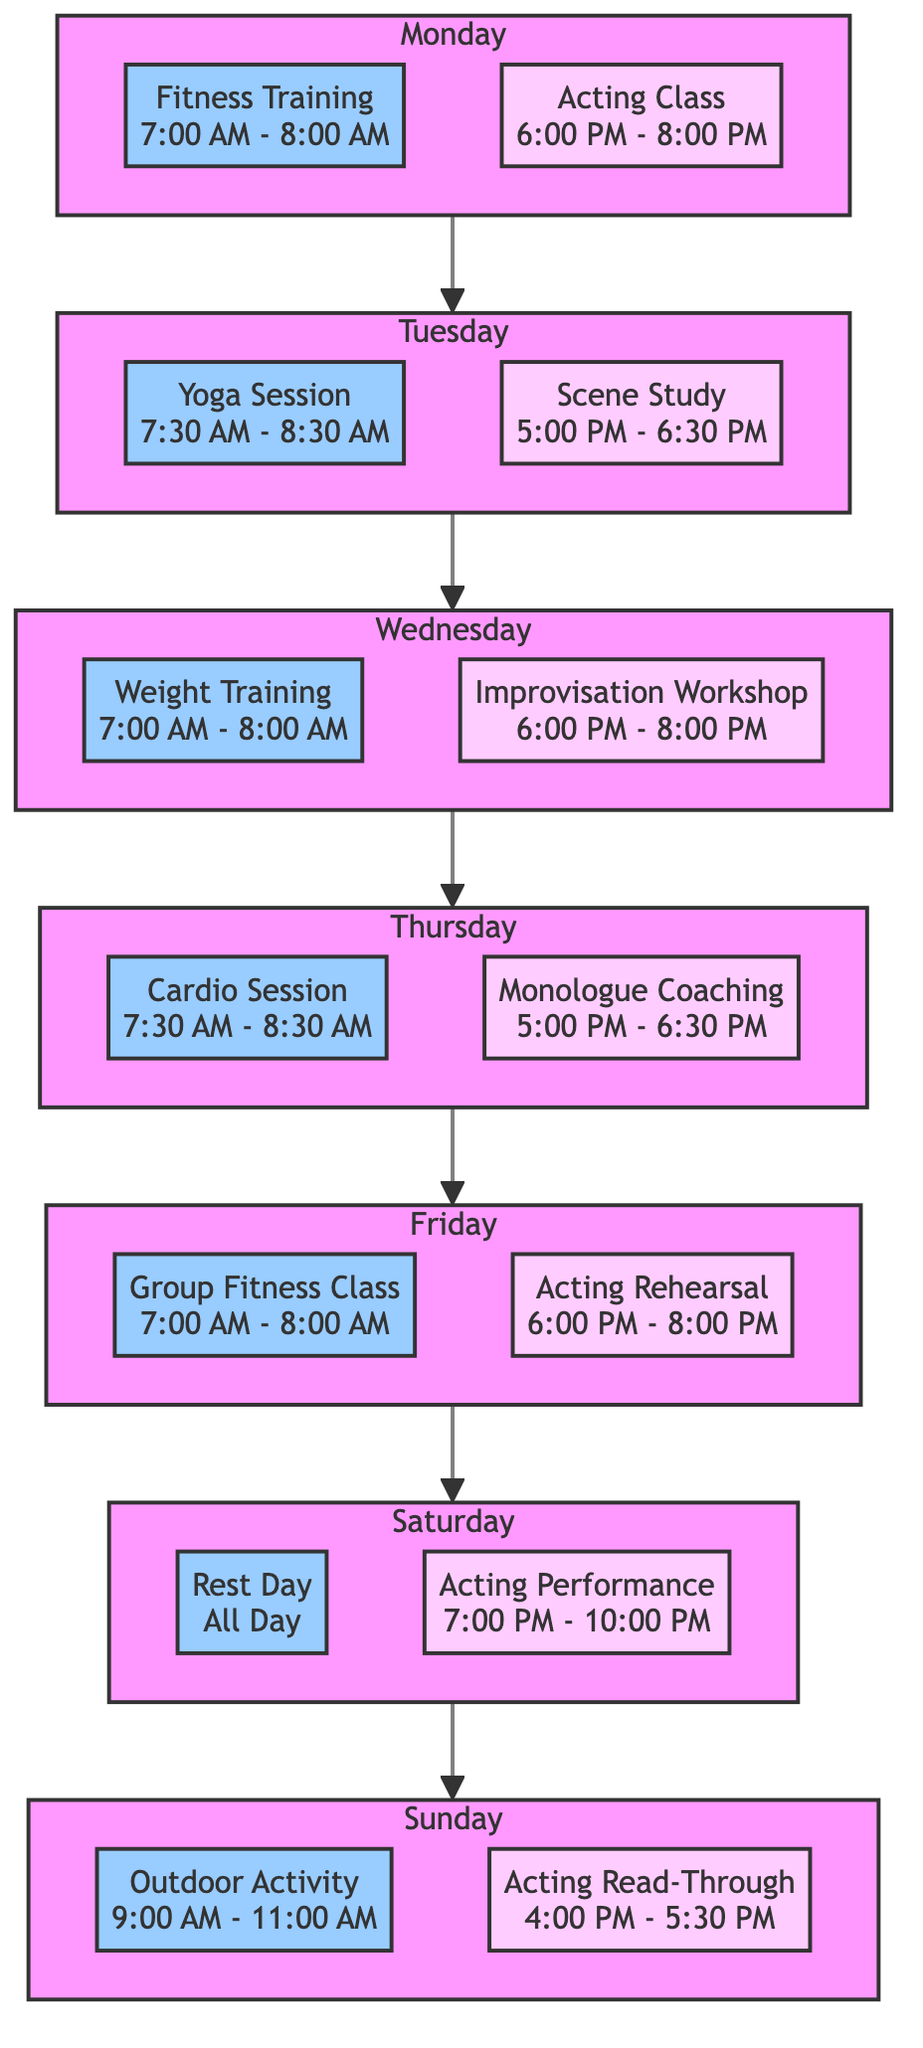What fitness activity is scheduled for Wednesday? The diagram indicates that on Wednesday, there is a "Weight Training" session from 7:00 AM to 8:00 AM.
Answer: Weight Training How many acting classes are there during the week? By counting the activities listed under each day for acting, there are a total of four classes: Acting Class on Monday, Scene Study on Tuesday, Improvisation Workshop on Wednesday, Monologue Coaching on Thursday, Acting Rehearsal on Friday, Acting Performance on Saturday, and Acting Read-Through on Sunday. However, only four are distinct classes.
Answer: 4 What time does the Yoga Session start? According to the diagram, the Yoga Session is scheduled for Tuesday from 7:30 AM to 8:30 AM, so it starts at 7:30 AM.
Answer: 7:30 AM Which day has a Rest Day scheduled? The diagram shows that Saturday is designated as a "Rest Day," with no scheduled training or classes.
Answer: Saturday What is the total duration of the Monday activities? On Monday, the Fitness Training lasts for 1 hour and the Acting Class is 2 hours long. Adding these gives a total of 3 hours for Monday activities.
Answer: 3 hours On which day is an Acting Performance taking place? The diagram clearly labels Saturday as the day for an "Acting Performance" scheduled from 7:00 PM to 10:00 PM.
Answer: Saturday What type of fitness activity is scheduled first in the week? The first fitness activity of the week, as indicated in the diagram, is "Fitness Training" on Monday from 7:00 AM to 8:00 AM.
Answer: Fitness Training How long is the Scene Study class? The diagram states that the Scene Study class on Tuesday lasts for 1.5 hours.
Answer: 1.5 hours What day has the longest acting-related activity? According to the diagram, the "Acting Performance" on Saturday lasts for around 3 hours, making it the longest acting-related activity in the schedule.
Answer: Saturday 